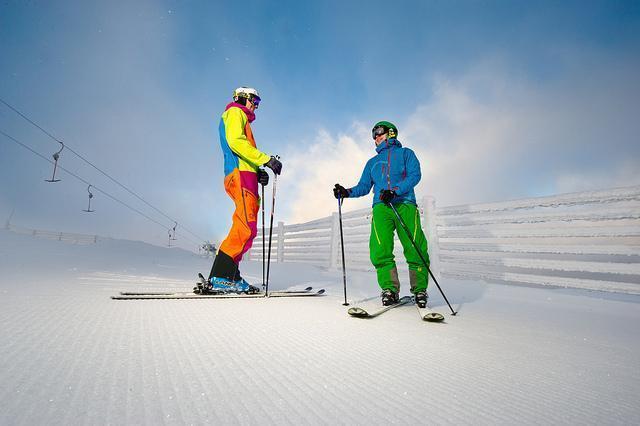How many skies are there?
Give a very brief answer. 4. How many people are there?
Give a very brief answer. 2. How many elephants in the picture?
Give a very brief answer. 0. 